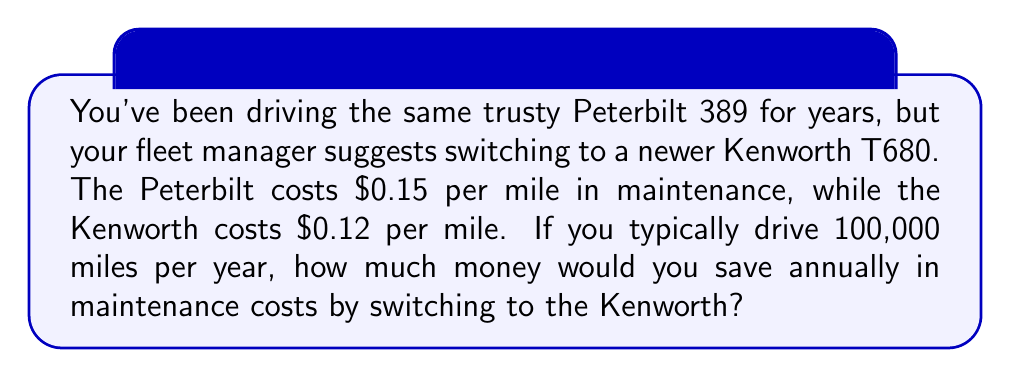Solve this math problem. Let's approach this step-by-step:

1) First, let's calculate the annual maintenance cost for the Peterbilt 389:
   $$\text{Peterbilt cost} = \$0.15 \text{ per mile} \times 100,000 \text{ miles} = \$15,000$$

2) Now, let's calculate the annual maintenance cost for the Kenworth T680:
   $$\text{Kenworth cost} = \$0.12 \text{ per mile} \times 100,000 \text{ miles} = \$12,000$$

3) To find the savings, we subtract the Kenworth cost from the Peterbilt cost:
   $$\text{Annual savings} = \$15,000 - \$12,000 = \$3,000$$

Therefore, by switching to the Kenworth T680, you would save $3,000 annually on maintenance costs.
Answer: $3,000 